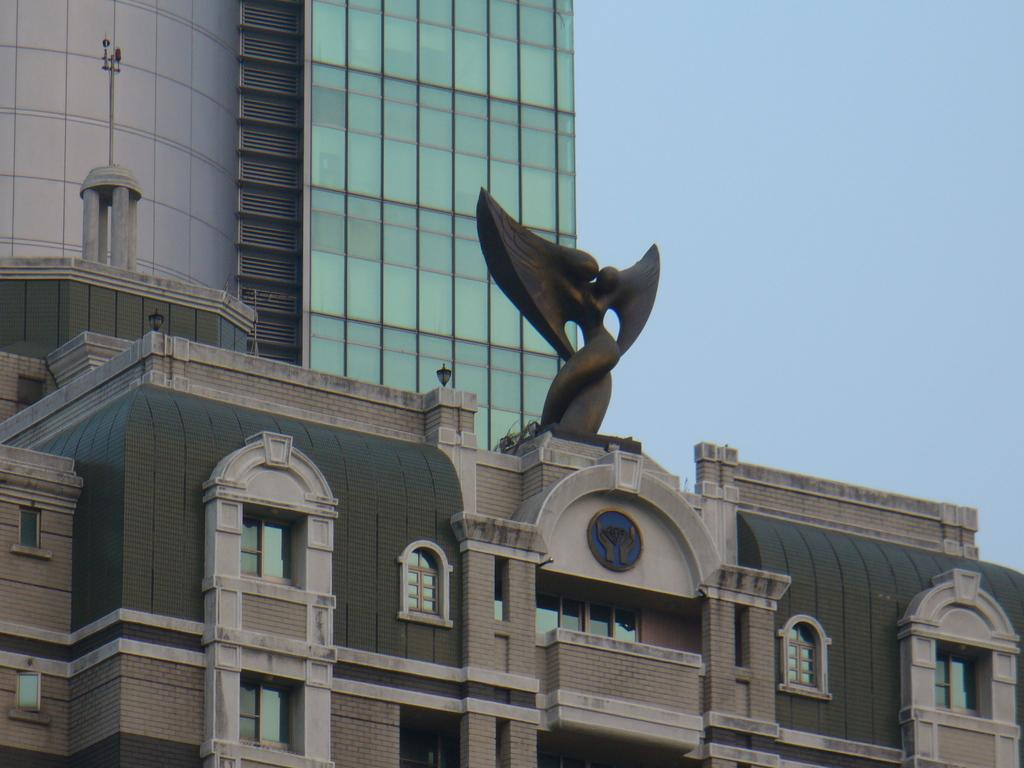What type of structure is present in the image? There is a building in the image. What part of the natural environment can be seen in the image? The sky is visible in the image. What type of chin can be seen on the scarecrow in the image? There is no scarecrow present in the image, so there is no chin to observe. 